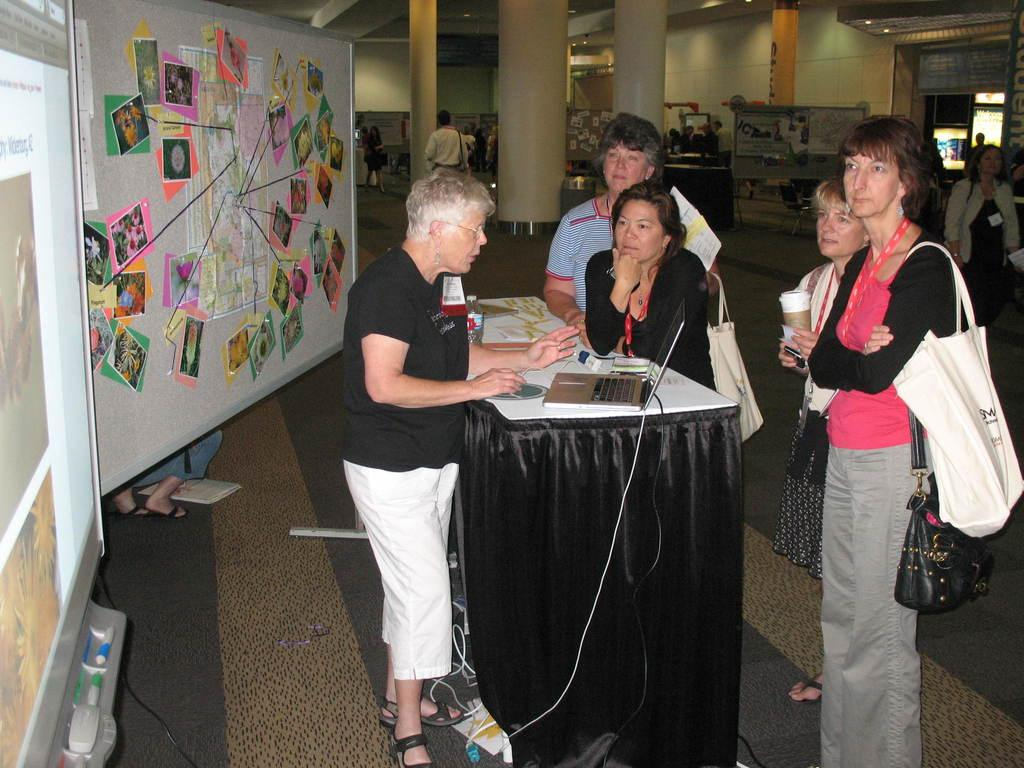What are the people in the image doing? There are people standing in the image, and one person at the left is operating a laptop. What is on the board in the image? There is a board with papers in the image. What architectural feature can be seen in the background of the image? There are pillars visible in the background of the image. How many people are crying in the image? There is no indication in the image that anyone is crying; the people are standing and one is operating a laptop. What type of collar is visible on the person at the right? There is no collar visible on the person at the right, as the image only shows them standing and not wearing any clothing that would reveal a collar. 